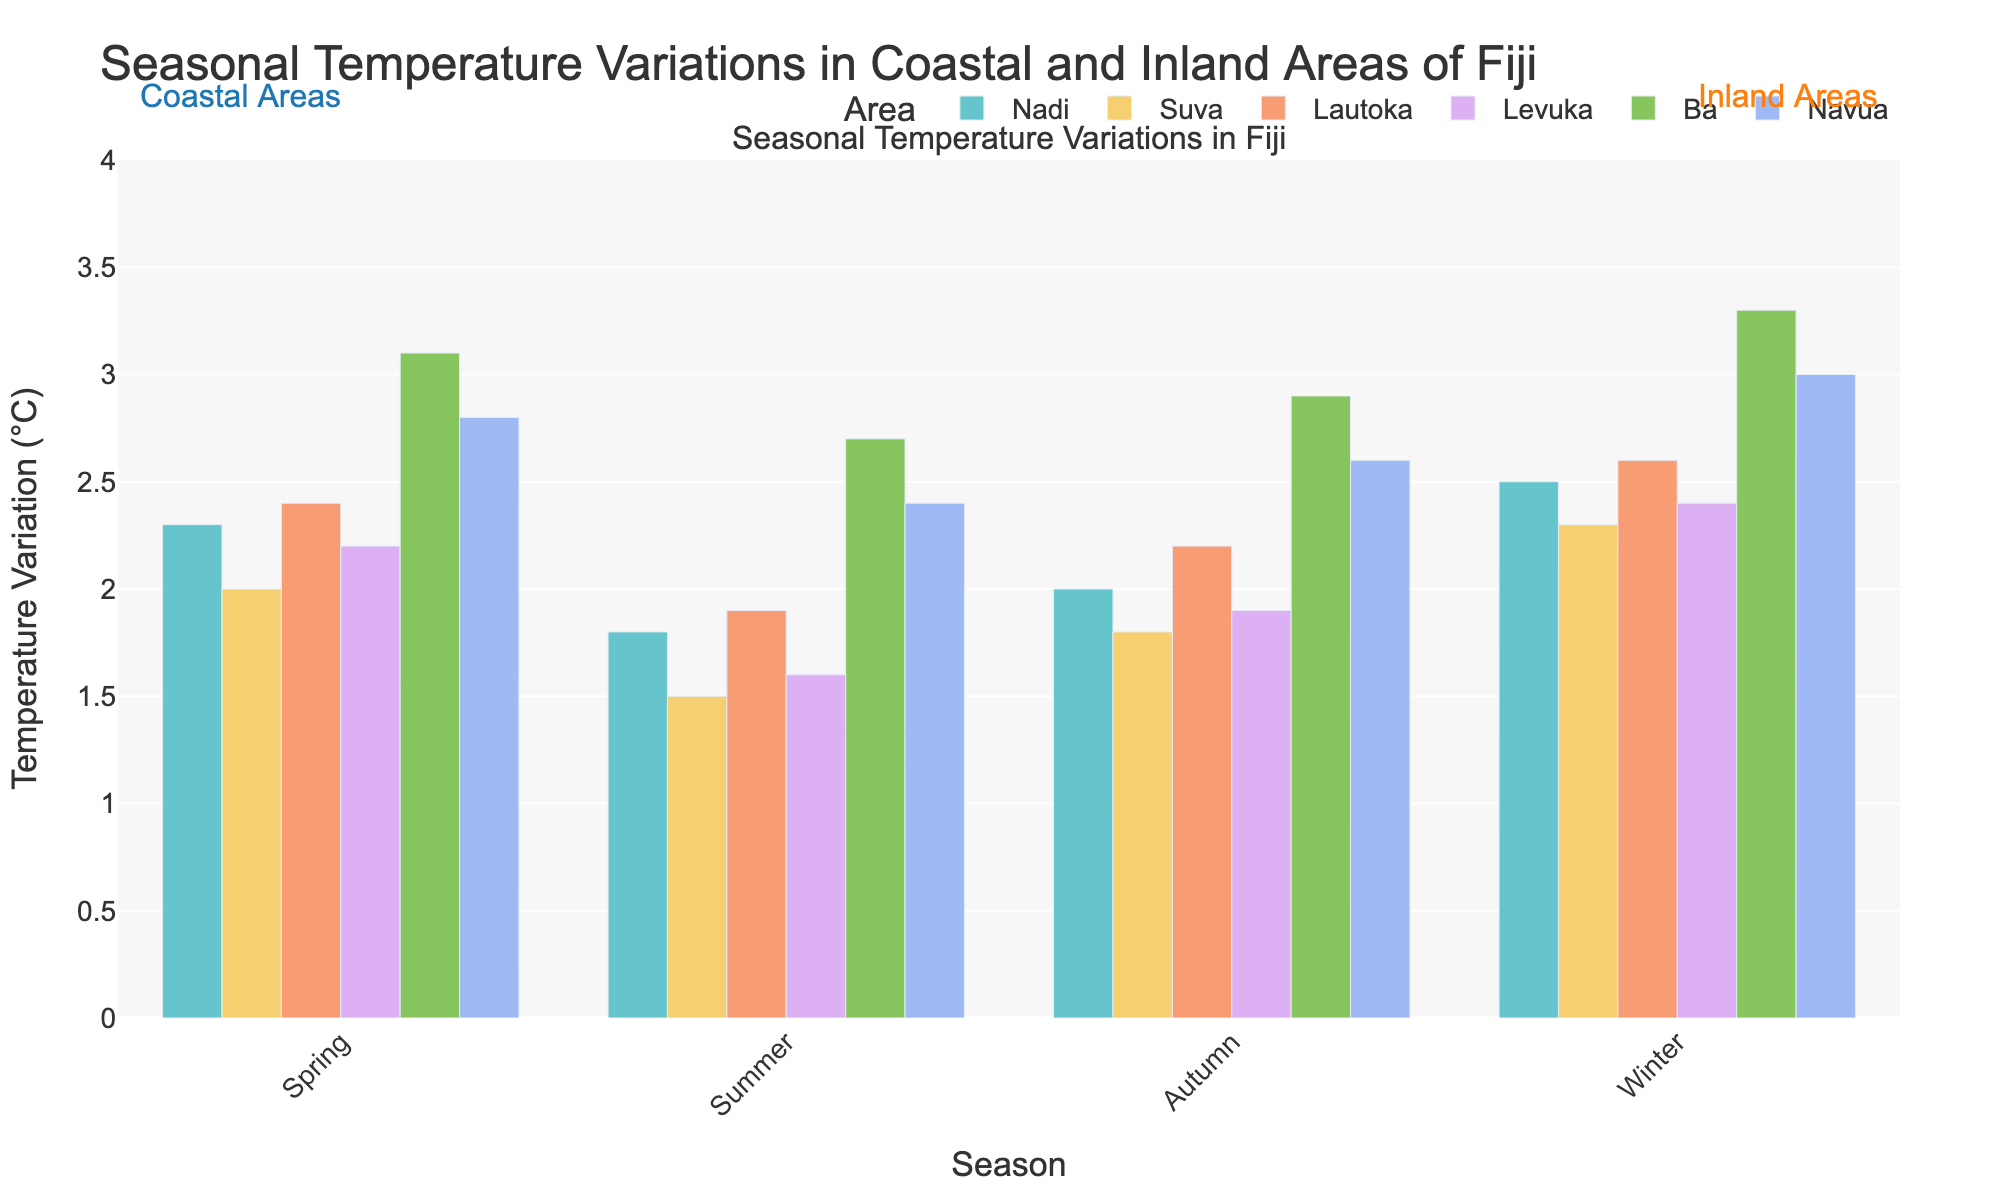Which area experiences the highest temperature variation in winter? By inspecting the bars corresponding to winter for each area, the tallest bar represents the highest temperature variation. Ba has the tallest bar in winter.
Answer: Ba How does Suva's temperature variation in summer compare to Navua's in summer? Comparing the heights of the bars for Suva and Navua in the summer season, Suva's bar is shorter than Navua's, indicating Suva has a lower temperature variation.
Answer: Suva's temperature variation is lower What is the average temperature variation for Nadi over all seasons? Sum the temperature variations for Nadi (2.3 + 1.8 + 2.0 + 2.5) = 8.6, then divide by the number of seasons (4).
Answer: 2.15 Which season has the smallest temperature variation in Levuka? By inspecting the bars for Levuka across all seasons, the shortest bar will indicate the smallest temperature variation. The shortest bar for Levuka occurs in summer.
Answer: Summer Is the temperature variation in Lautoka higher in autumn or spring? By comparing the bars for Lautoka in autumn and spring, the height of the autumn bar is slightly shorter than the spring bar, indicating that spring has a higher temperature variation.
Answer: Spring Calculate the difference in temperature variation between Ba and Navua in autumn. By subtracting Navua's temperature variation in autumn (2.6) from Ba's variation in autumn (2.9), the difference is 2.9 - 2.6.
Answer: 0.3 Do inland areas generally have higher temperature variations than coastal areas in winter? Comparing the bar heights of all inland areas (Ba, Navua) with coastal areas (Nadi, Suva, Lautoka, Levuka) in winter, inland areas (3.3, 3.0) consistently show higher temperatures than coastal (2.5, 2.3, 2.6, 2.4).
Answer: Yes Is there any season where Nadi and Lautoka have the same temperature variation? By comparing the heights of the bars for Nadi and Lautoka across all seasons, no bars are equal in height, indicating there is no season where their variations are the same.
Answer: No Calculate the total temperature variation for all areas in spring. Sum the temperature variations for all areas in spring (2.3 + 2.0 + 2.4 + 2.2 + 3.1 + 2.8) = 14.8.
Answer: 14.8 In which season do coastal areas exhibit the least temperature variation on average? Calculate the average temperature variation for coastal areas in each season and find the season with the smallest value: Spring (2.3 + 2.0 + 2.4 + 2.2)/4 = 2.225, Summer (1.8 + 1.5 + 1.9 + 1.6)/4 = 1.7, Autumn (2.0 + 1.8 + 2.2 + 1.9)/4 = 1.975, Winter (2.5 + 2.3 + 2.6 + 2.4)/4 = 2.45. The smallest average is in summer.
Answer: Summer 